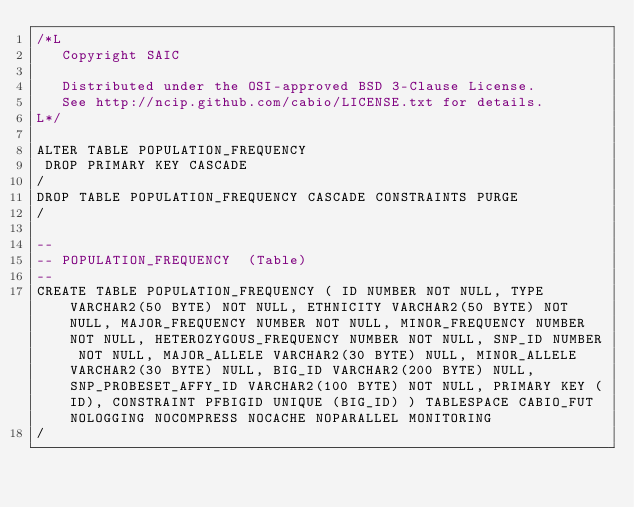Convert code to text. <code><loc_0><loc_0><loc_500><loc_500><_SQL_>/*L
   Copyright SAIC

   Distributed under the OSI-approved BSD 3-Clause License.
   See http://ncip.github.com/cabio/LICENSE.txt for details.
L*/

ALTER TABLE POPULATION_FREQUENCY
 DROP PRIMARY KEY CASCADE
/
DROP TABLE POPULATION_FREQUENCY CASCADE CONSTRAINTS PURGE
/

--
-- POPULATION_FREQUENCY  (Table) 
--
CREATE TABLE POPULATION_FREQUENCY ( ID NUMBER NOT NULL, TYPE VARCHAR2(50 BYTE) NOT NULL, ETHNICITY VARCHAR2(50 BYTE) NOT NULL, MAJOR_FREQUENCY NUMBER NOT NULL, MINOR_FREQUENCY NUMBER NOT NULL, HETEROZYGOUS_FREQUENCY NUMBER NOT NULL, SNP_ID NUMBER NOT NULL, MAJOR_ALLELE VARCHAR2(30 BYTE) NULL, MINOR_ALLELE VARCHAR2(30 BYTE) NULL, BIG_ID VARCHAR2(200 BYTE) NULL, SNP_PROBESET_AFFY_ID VARCHAR2(100 BYTE) NOT NULL, PRIMARY KEY (ID), CONSTRAINT PFBIGID UNIQUE (BIG_ID) ) TABLESPACE CABIO_FUT NOLOGGING NOCOMPRESS NOCACHE NOPARALLEL MONITORING
/


</code> 